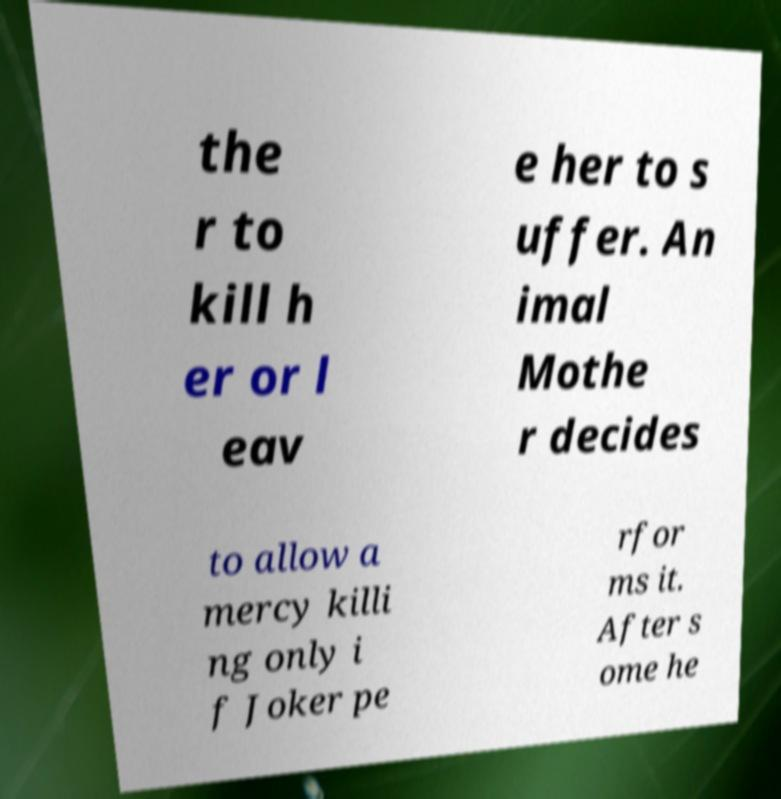Can you read and provide the text displayed in the image?This photo seems to have some interesting text. Can you extract and type it out for me? the r to kill h er or l eav e her to s uffer. An imal Mothe r decides to allow a mercy killi ng only i f Joker pe rfor ms it. After s ome he 